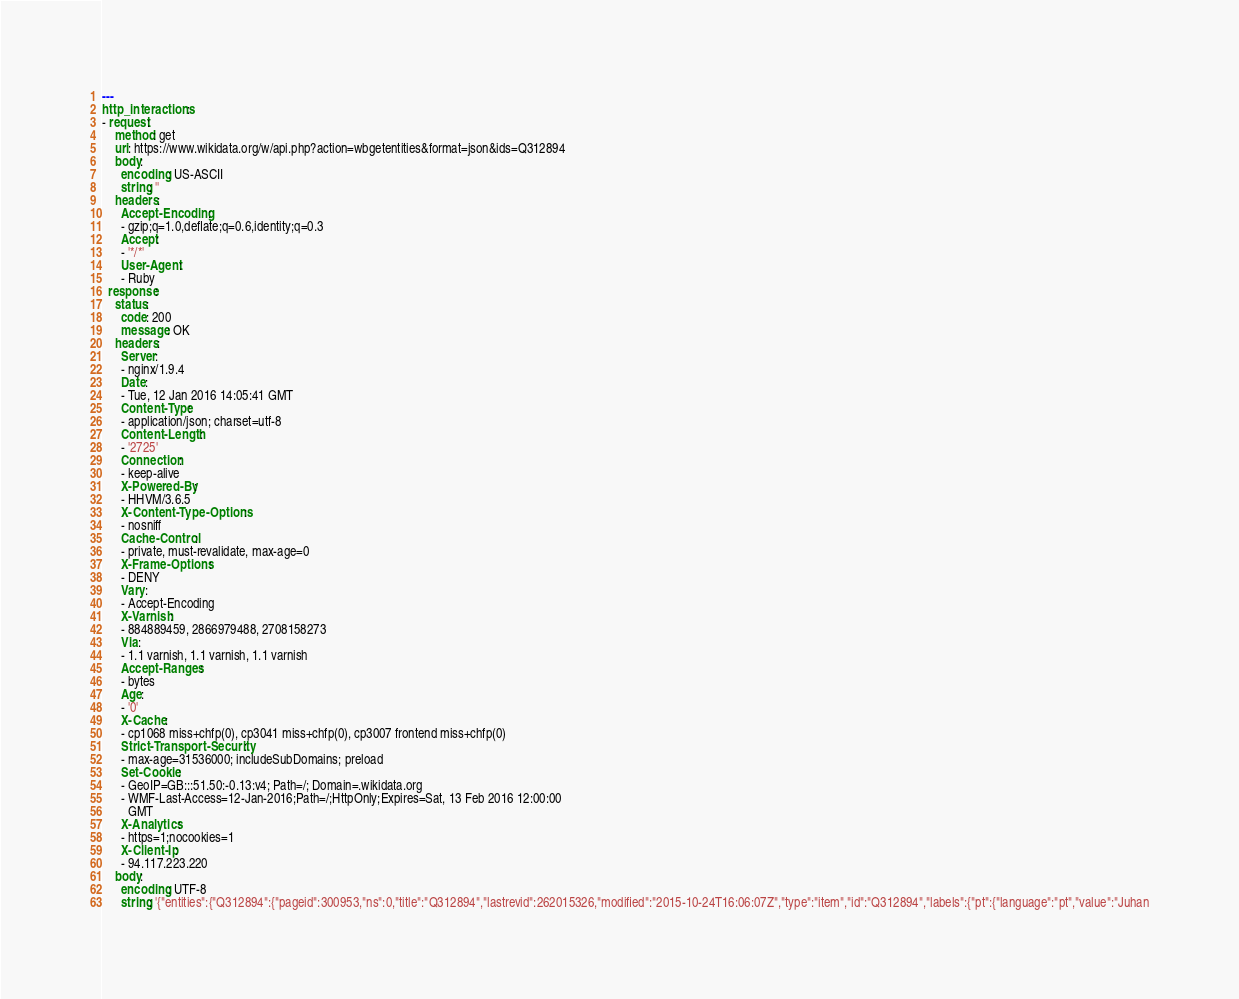<code> <loc_0><loc_0><loc_500><loc_500><_YAML_>---
http_interactions:
- request:
    method: get
    uri: https://www.wikidata.org/w/api.php?action=wbgetentities&format=json&ids=Q312894
    body:
      encoding: US-ASCII
      string: ''
    headers:
      Accept-Encoding:
      - gzip;q=1.0,deflate;q=0.6,identity;q=0.3
      Accept:
      - '*/*'
      User-Agent:
      - Ruby
  response:
    status:
      code: 200
      message: OK
    headers:
      Server:
      - nginx/1.9.4
      Date:
      - Tue, 12 Jan 2016 14:05:41 GMT
      Content-Type:
      - application/json; charset=utf-8
      Content-Length:
      - '2725'
      Connection:
      - keep-alive
      X-Powered-By:
      - HHVM/3.6.5
      X-Content-Type-Options:
      - nosniff
      Cache-Control:
      - private, must-revalidate, max-age=0
      X-Frame-Options:
      - DENY
      Vary:
      - Accept-Encoding
      X-Varnish:
      - 884889459, 2866979488, 2708158273
      Via:
      - 1.1 varnish, 1.1 varnish, 1.1 varnish
      Accept-Ranges:
      - bytes
      Age:
      - '0'
      X-Cache:
      - cp1068 miss+chfp(0), cp3041 miss+chfp(0), cp3007 frontend miss+chfp(0)
      Strict-Transport-Security:
      - max-age=31536000; includeSubDomains; preload
      Set-Cookie:
      - GeoIP=GB:::51.50:-0.13:v4; Path=/; Domain=.wikidata.org
      - WMF-Last-Access=12-Jan-2016;Path=/;HttpOnly;Expires=Sat, 13 Feb 2016 12:00:00
        GMT
      X-Analytics:
      - https=1;nocookies=1
      X-Client-Ip:
      - 94.117.223.220
    body:
      encoding: UTF-8
      string: '{"entities":{"Q312894":{"pageid":300953,"ns":0,"title":"Q312894","lastrevid":262015326,"modified":"2015-10-24T16:06:07Z","type":"item","id":"Q312894","labels":{"pt":{"language":"pt","value":"Juhan</code> 